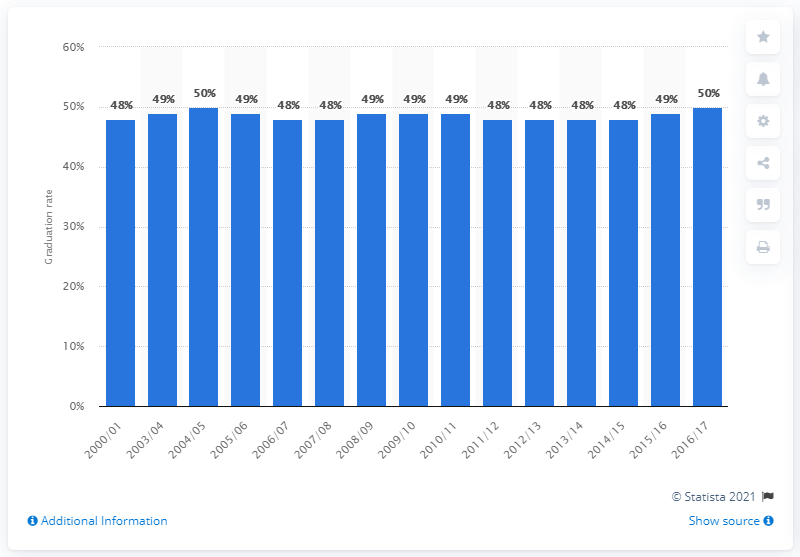Mention a couple of crucial points in this snapshot. The graduation rate in 2017/18 was 50%. The graduation rate for higher education in the United States began in academic year 2000/2001. In the United States, the higher education graduation rate changed from the academic years 2000/01 to 2016/17. 